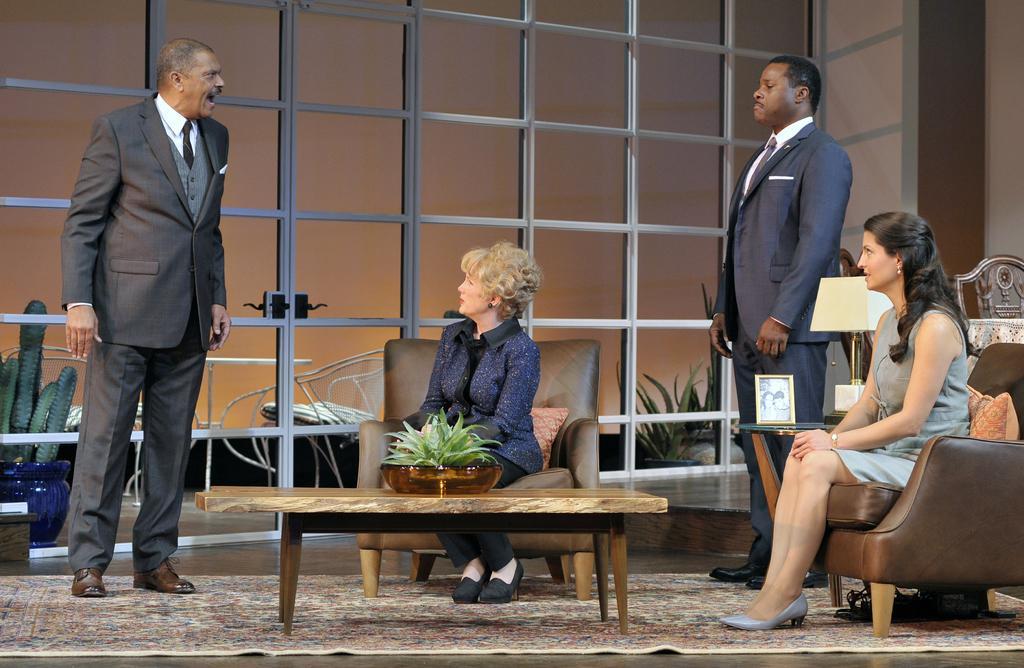How would you summarize this image in a sentence or two? In the image there is a man stood at left side corner wore a suit talking and in middle there is a woman sat on sofa and on right side there is another woman sat on sofa,beside her there is another man stood. 